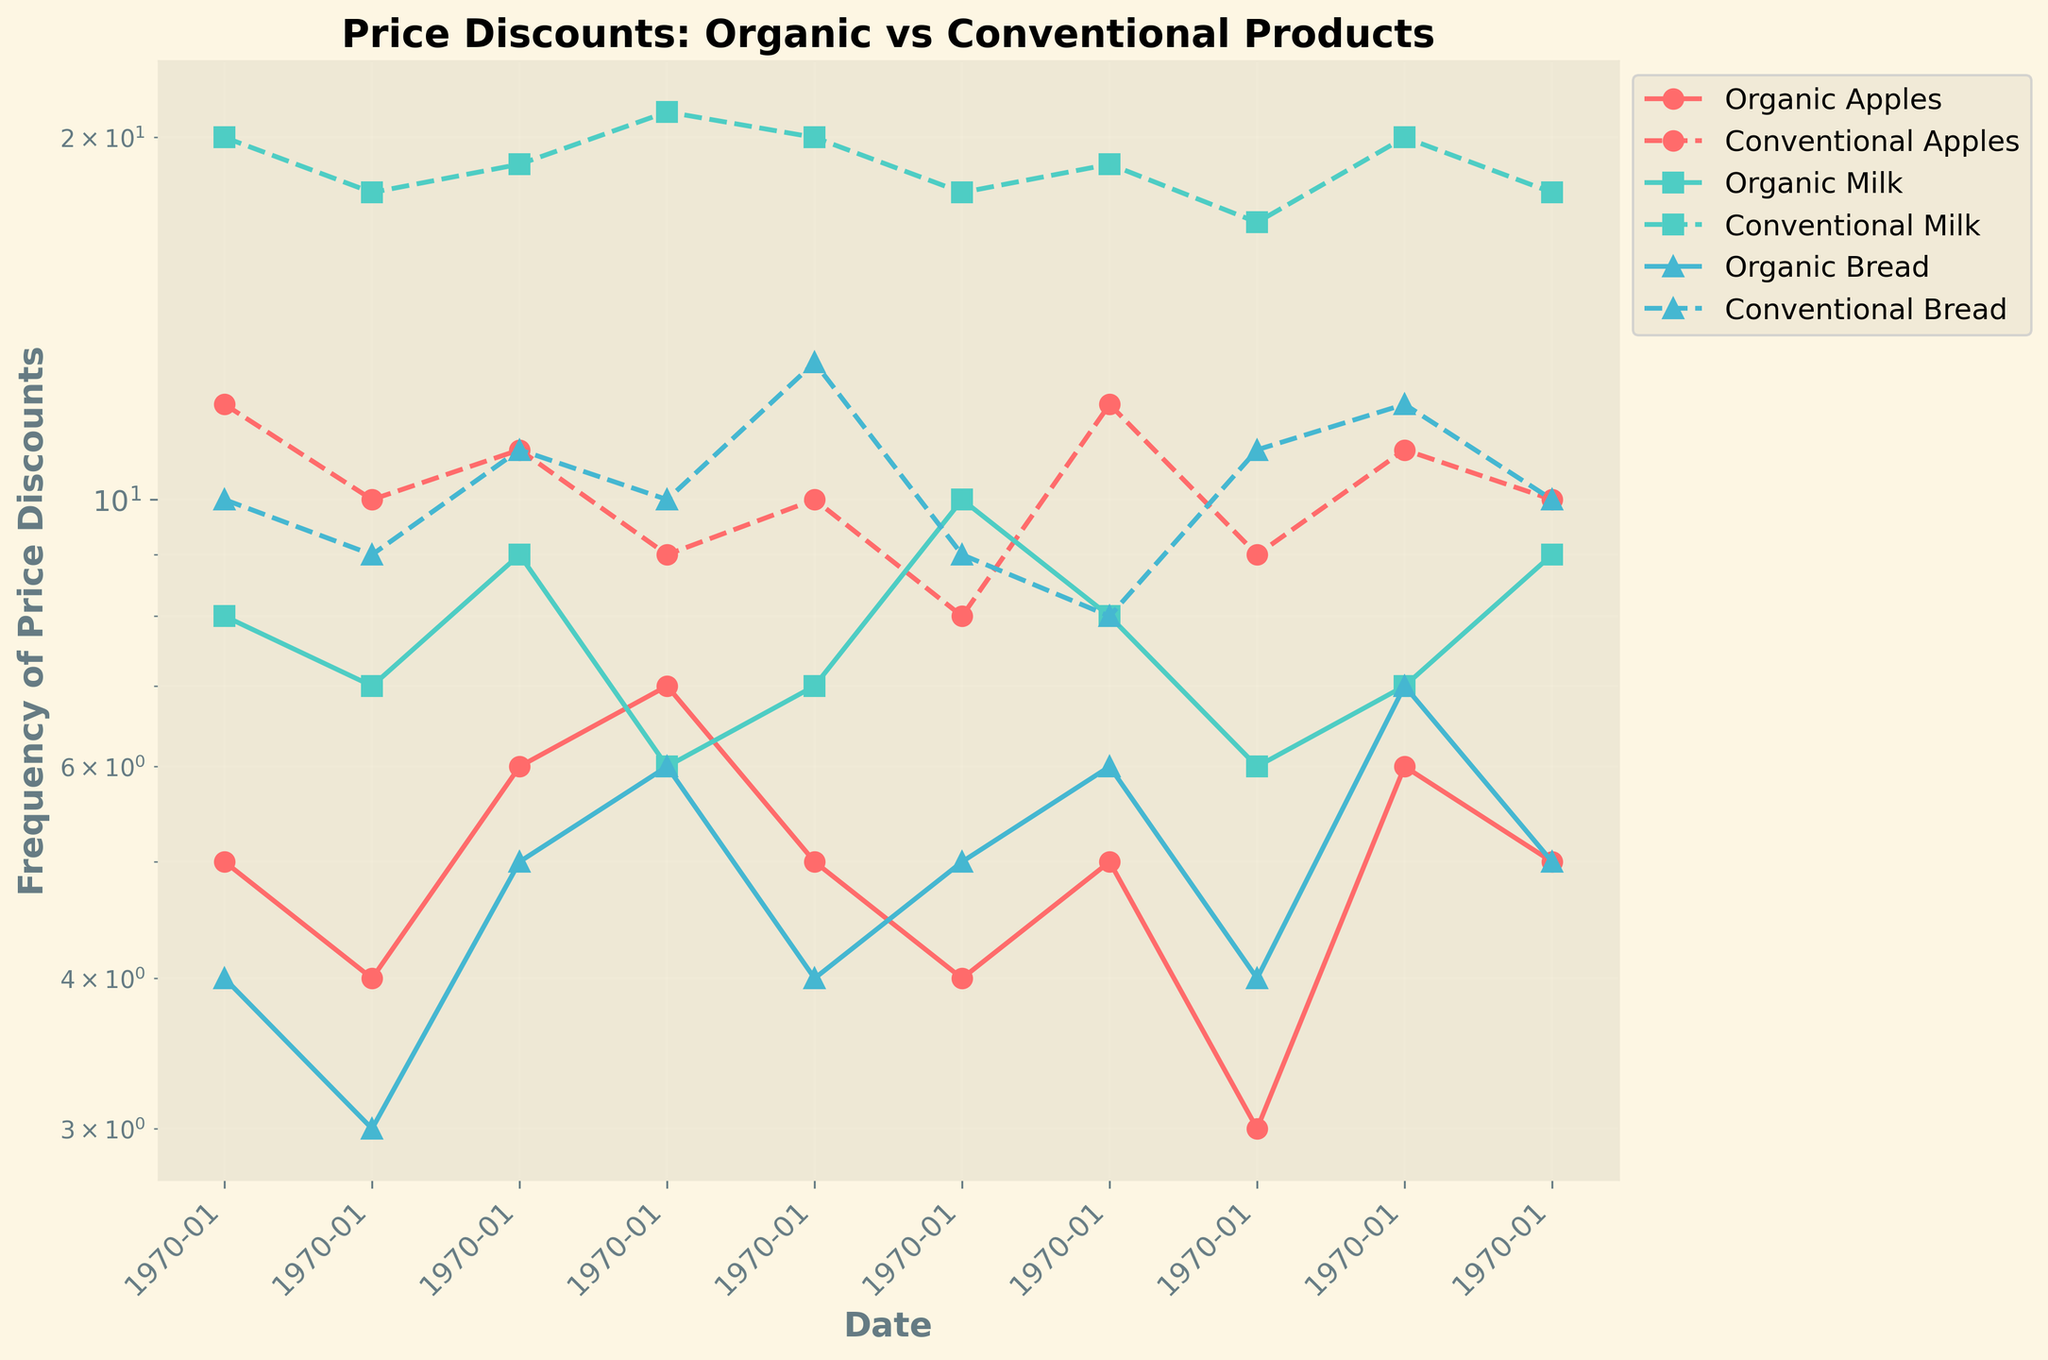What is the title of the figure? The title is located at the top of the figure in bold text. It reads "Price Discounts: Organic vs Conventional Products"
Answer: Price Discounts: Organic vs Conventional Products How does the frequency of price discounts for conventional apples change over time? The figure shows data points connected by a dashed line (conventional apples), tracking from January to October. The frequency fluctuates slightly but generally remains within the range of 8 to 12 times per month.
Answer: Fluctuates between 8 to 12 times per month Which product shows the highest variability in frequency of price discounts over time for organic items? Observing the organic lines (solid lines with different colors), the organic bread line shows the most variability, as it fluctuates the most over the months.
Answer: Organic bread On which date did organic milk experience the lowest frequency of price discounts? Looking at the solid line for organic milk (represented in the second color and shape, usually green), the lowest point occurs on April 1, where the frequency is 6.
Answer: April 1 Compare the frequency of price discounts for organic and conventional milk in July. Which is higher? Check the points on the figure for July. The solid line for organic milk and the dashed line for conventional milk: organic has a value of 8, and conventional has 19.
Answer: Conventional milk What was the average frequency of price discounts for conventional bread from January to October? Add up the values for conventional bread (10, 9, 11, 10, 13, 9, 8, 11, 12, 10), then divide by 10. Total is (10+9+11+10+13+9+8+11+12+10) = 103, so average is 103/10.
Answer: 10.3 Which organic item had the highest frequency of price discounts in September? Reviewing the points for September, we compare the values for organic apples (6), organic milk (7), and organic bread (7). The highest frequency is a tie between milk and bread.
Answer: Organic milk and organic bread From January to October, which product shows the least difference between the highest and lowest frequency of price discounts for conventional items? Calculate the difference for each conventional product: Apples (12-8=4), Milk (21-17=4), Bread (13-8=5). Both conventional apples and milk have the smallest difference.
Answer: Conventional apples and conventional milk In which month do organic apples and conventional milk share the same frequency of price discounts? Examine the lines for organic apples (solid line) and conventional milk (dashed line) month by month. Both reach 7 in June.
Answer: June 